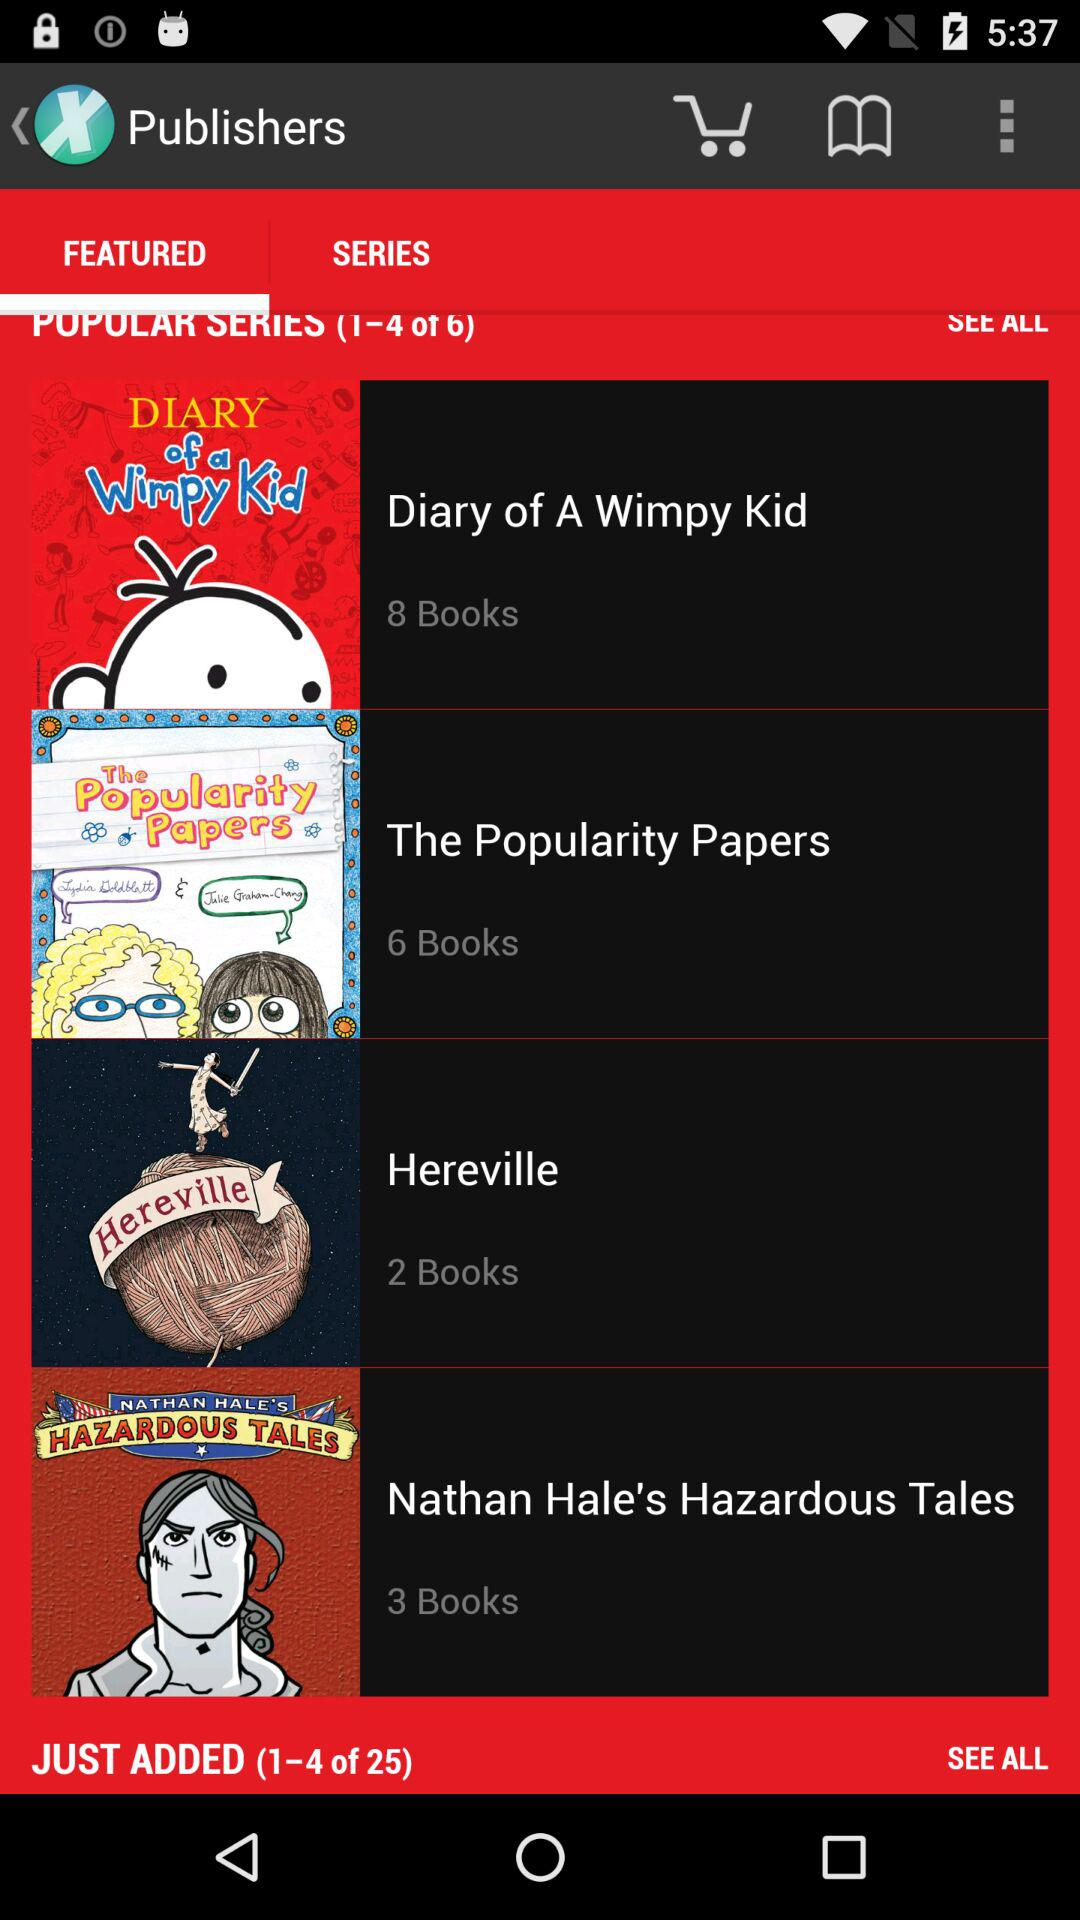How many more books are in the series 'Diary of a Wimpy Kid' than 'Hereville'?
Answer the question using a single word or phrase. 6 